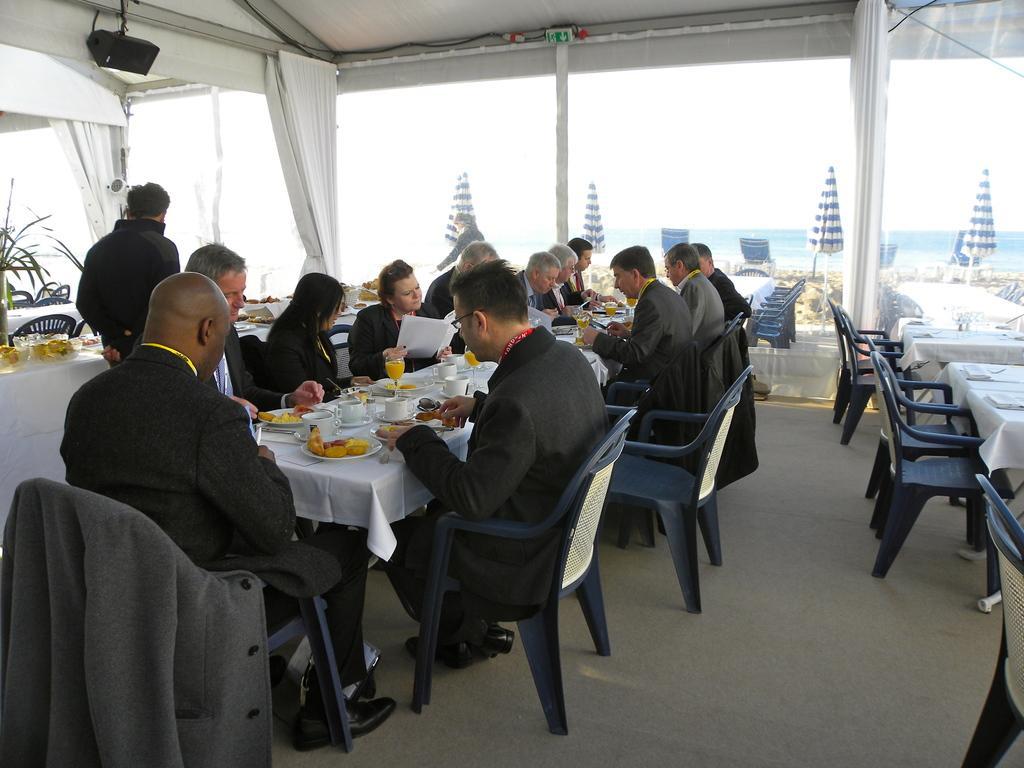How would you summarize this image in a sentence or two? In this picture we can see group of people sitting on chairs and having their lunch on table and on table we can see plates, cup, glass with food and drinks and in background we can see sky, chairs, umbrella with poles, curtains and here the man kept coat on the chair. 